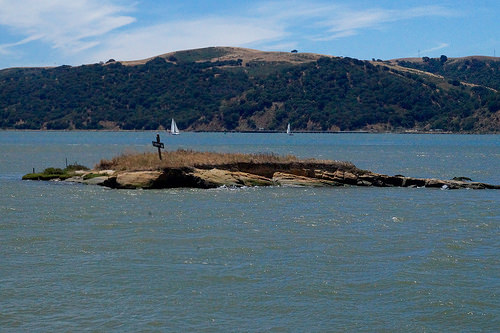<image>
Is there a plants on the hill? Yes. Looking at the image, I can see the plants is positioned on top of the hill, with the hill providing support. Where is the water in relation to the mountain? Is it behind the mountain? Yes. From this viewpoint, the water is positioned behind the mountain, with the mountain partially or fully occluding the water. 